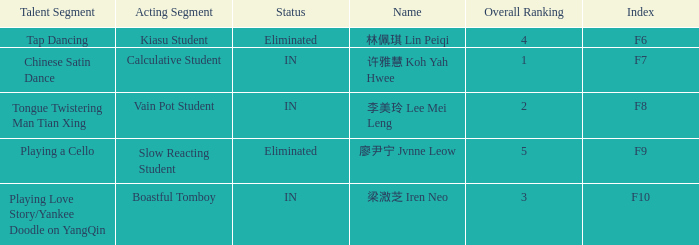For the event with index f7, what is the status? IN. 